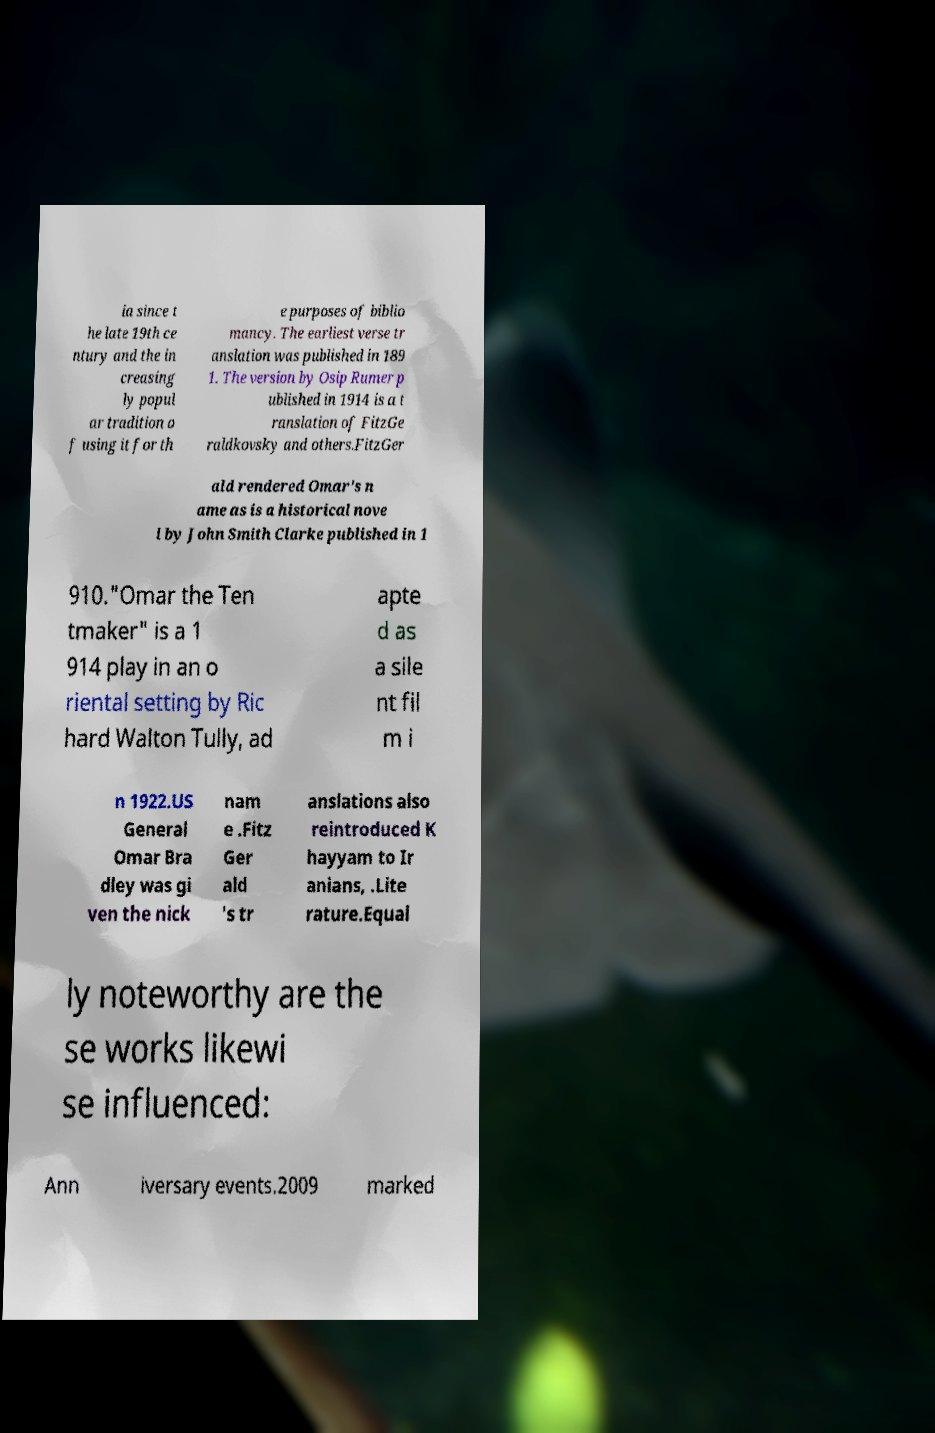Please identify and transcribe the text found in this image. ia since t he late 19th ce ntury and the in creasing ly popul ar tradition o f using it for th e purposes of biblio mancy. The earliest verse tr anslation was published in 189 1. The version by Osip Rumer p ublished in 1914 is a t ranslation of FitzGe raldkovsky and others.FitzGer ald rendered Omar's n ame as is a historical nove l by John Smith Clarke published in 1 910."Omar the Ten tmaker" is a 1 914 play in an o riental setting by Ric hard Walton Tully, ad apte d as a sile nt fil m i n 1922.US General Omar Bra dley was gi ven the nick nam e .Fitz Ger ald 's tr anslations also reintroduced K hayyam to Ir anians, .Lite rature.Equal ly noteworthy are the se works likewi se influenced: Ann iversary events.2009 marked 